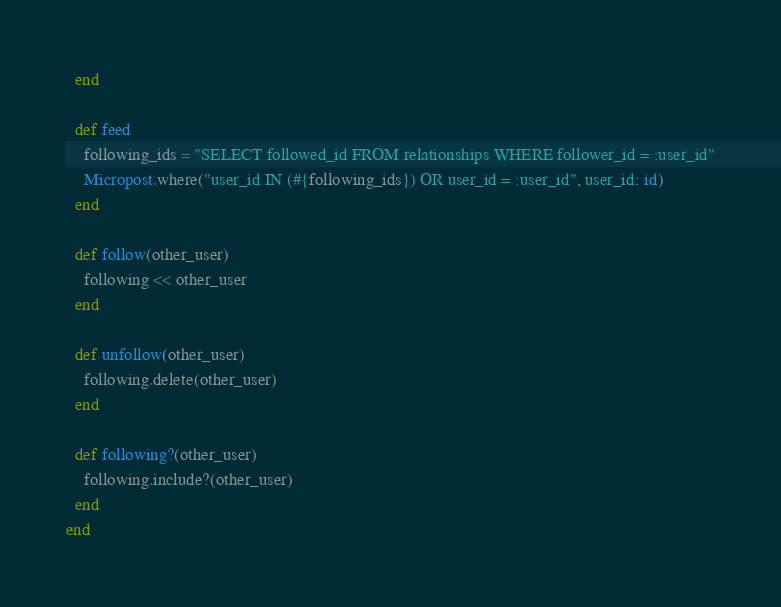<code> <loc_0><loc_0><loc_500><loc_500><_Ruby_>  end

  def feed
    following_ids = "SELECT followed_id FROM relationships WHERE follower_id = :user_id"
    Micropost.where("user_id IN (#{following_ids}) OR user_id = :user_id", user_id: id)
  end

  def follow(other_user)
    following << other_user
  end

  def unfollow(other_user)
    following.delete(other_user)
  end

  def following?(other_user)
    following.include?(other_user)
  end
end
</code> 